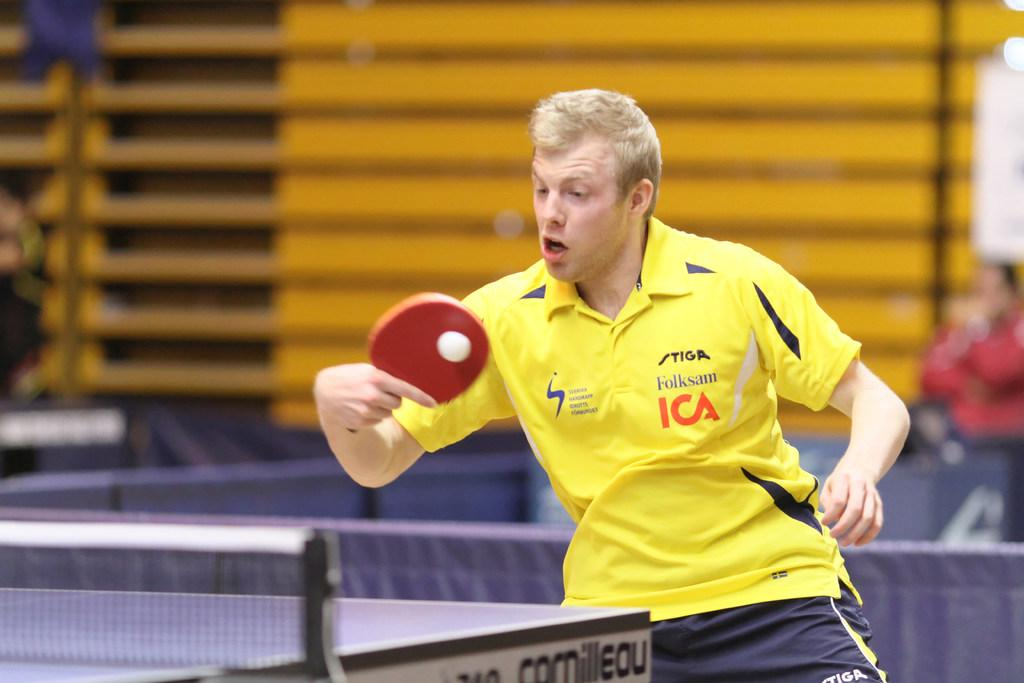<image>
Describe the image concisely. A ping pong player has Folksam and ICA on his shirt. 